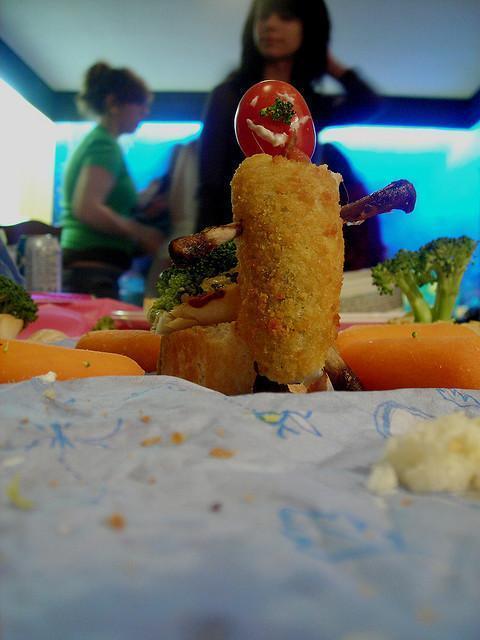How many people are in the photo?
Give a very brief answer. 2. How many broccolis are there?
Give a very brief answer. 2. How many carrots are in the picture?
Give a very brief answer. 3. How many people are there?
Give a very brief answer. 3. 